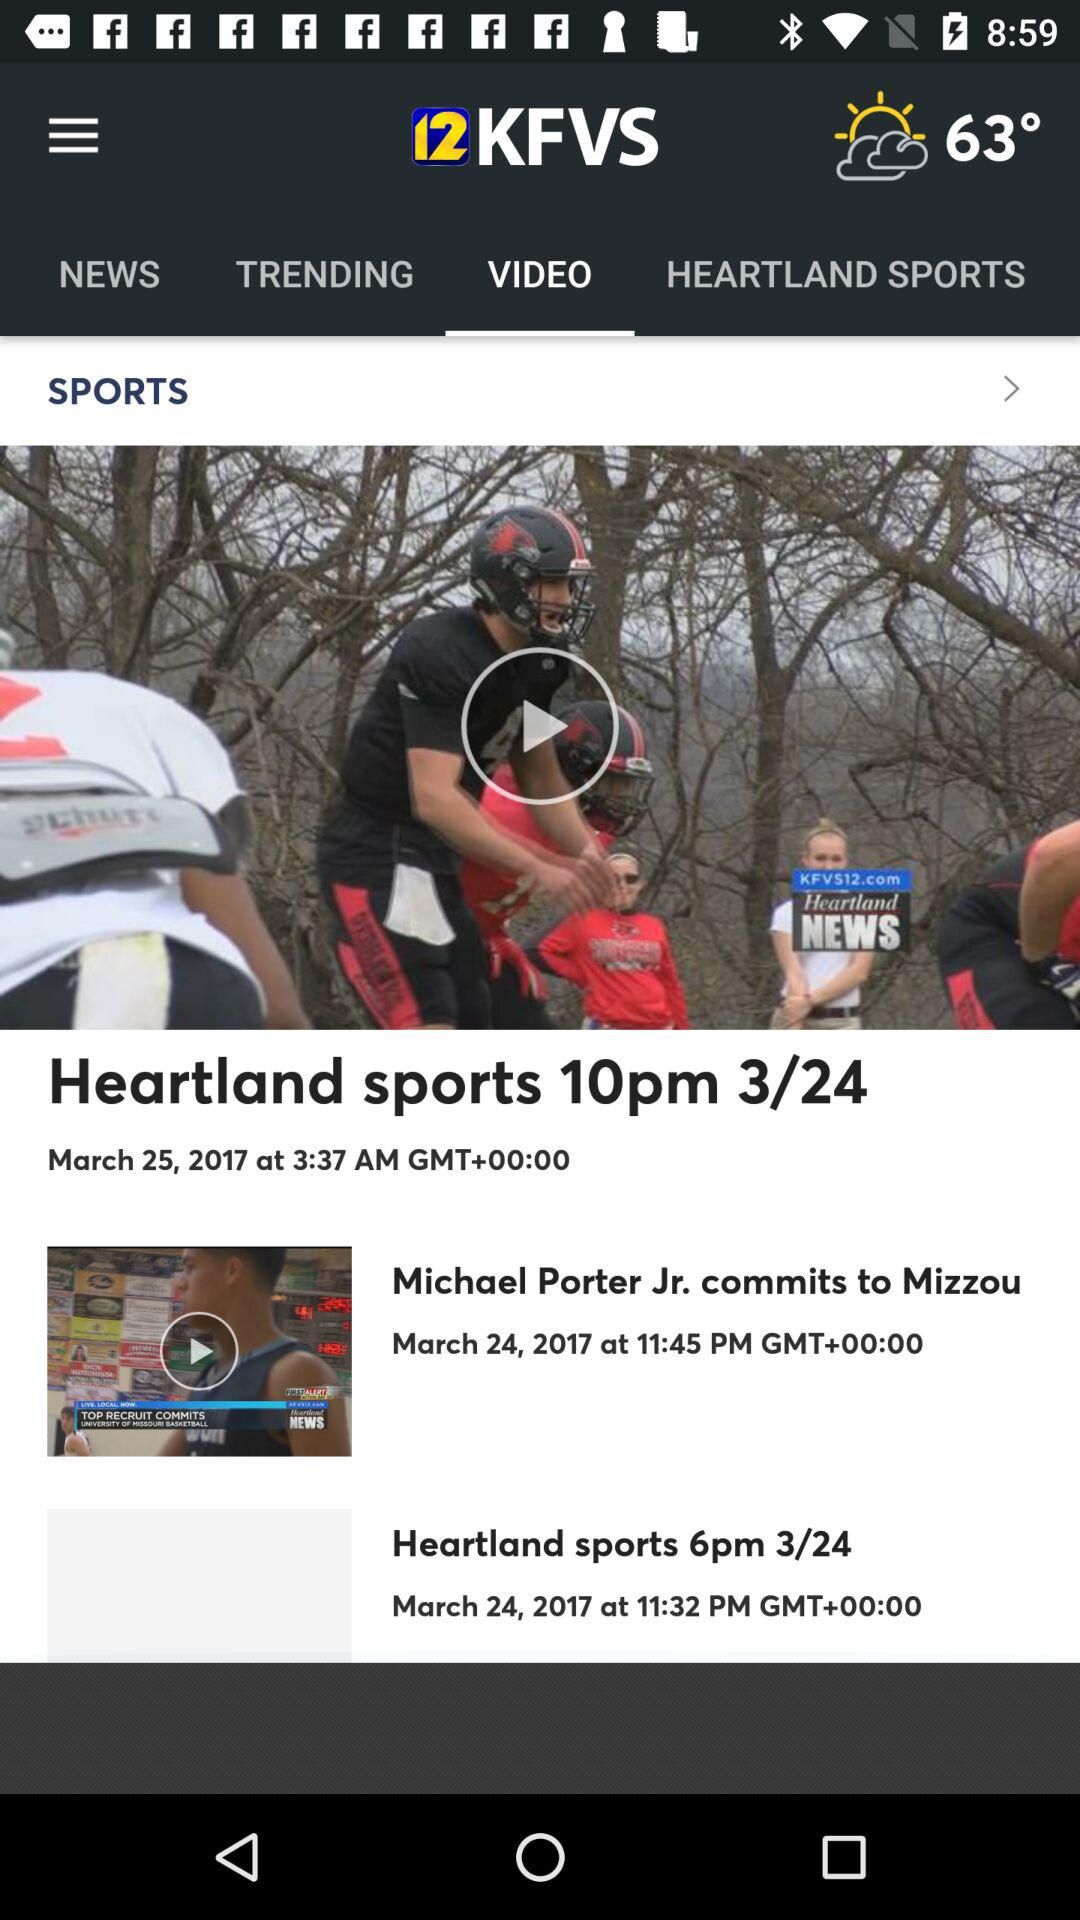What is the temperature? The temperature is 63°. 